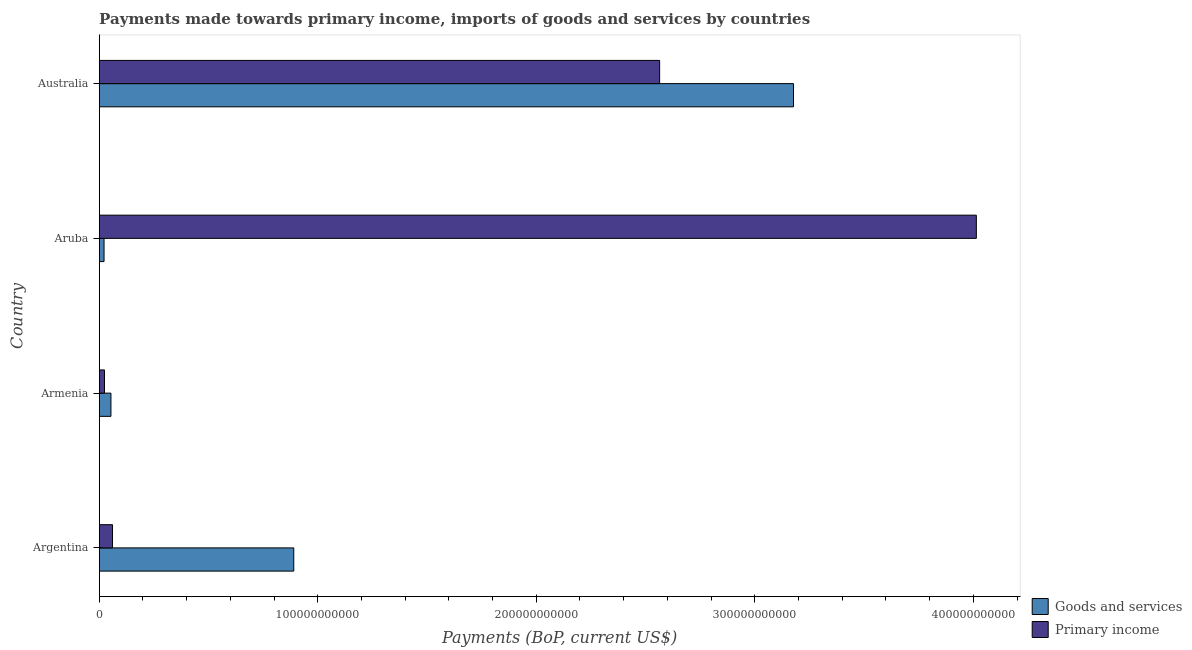How many different coloured bars are there?
Your answer should be compact. 2. How many groups of bars are there?
Give a very brief answer. 4. Are the number of bars per tick equal to the number of legend labels?
Your answer should be very brief. Yes. Are the number of bars on each tick of the Y-axis equal?
Provide a short and direct response. Yes. How many bars are there on the 1st tick from the bottom?
Offer a very short reply. 2. What is the label of the 4th group of bars from the top?
Provide a succinct answer. Argentina. In how many cases, is the number of bars for a given country not equal to the number of legend labels?
Your answer should be very brief. 0. What is the payments made towards goods and services in Aruba?
Provide a short and direct response. 2.21e+09. Across all countries, what is the maximum payments made towards goods and services?
Offer a terse response. 3.18e+11. Across all countries, what is the minimum payments made towards primary income?
Make the answer very short. 2.41e+09. In which country was the payments made towards goods and services maximum?
Ensure brevity in your answer.  Australia. In which country was the payments made towards primary income minimum?
Your answer should be very brief. Armenia. What is the total payments made towards goods and services in the graph?
Your answer should be compact. 4.14e+11. What is the difference between the payments made towards primary income in Armenia and that in Australia?
Offer a terse response. -2.54e+11. What is the difference between the payments made towards goods and services in Australia and the payments made towards primary income in Armenia?
Ensure brevity in your answer.  3.15e+11. What is the average payments made towards primary income per country?
Give a very brief answer. 1.67e+11. What is the difference between the payments made towards goods and services and payments made towards primary income in Argentina?
Your answer should be very brief. 8.29e+1. What is the ratio of the payments made towards primary income in Argentina to that in Armenia?
Your response must be concise. 2.52. Is the payments made towards goods and services in Armenia less than that in Australia?
Your answer should be compact. Yes. Is the difference between the payments made towards goods and services in Argentina and Australia greater than the difference between the payments made towards primary income in Argentina and Australia?
Keep it short and to the point. Yes. What is the difference between the highest and the second highest payments made towards primary income?
Your response must be concise. 1.45e+11. What is the difference between the highest and the lowest payments made towards goods and services?
Your response must be concise. 3.15e+11. In how many countries, is the payments made towards primary income greater than the average payments made towards primary income taken over all countries?
Give a very brief answer. 2. What does the 2nd bar from the top in Armenia represents?
Offer a very short reply. Goods and services. What does the 1st bar from the bottom in Argentina represents?
Offer a very short reply. Goods and services. How many bars are there?
Ensure brevity in your answer.  8. How many countries are there in the graph?
Offer a terse response. 4. What is the difference between two consecutive major ticks on the X-axis?
Your answer should be very brief. 1.00e+11. Are the values on the major ticks of X-axis written in scientific E-notation?
Provide a short and direct response. No. Does the graph contain any zero values?
Your answer should be very brief. No. Does the graph contain grids?
Provide a short and direct response. No. How many legend labels are there?
Make the answer very short. 2. What is the title of the graph?
Your response must be concise. Payments made towards primary income, imports of goods and services by countries. Does "ODA received" appear as one of the legend labels in the graph?
Offer a terse response. No. What is the label or title of the X-axis?
Ensure brevity in your answer.  Payments (BoP, current US$). What is the label or title of the Y-axis?
Offer a very short reply. Country. What is the Payments (BoP, current US$) in Goods and services in Argentina?
Provide a short and direct response. 8.90e+1. What is the Payments (BoP, current US$) in Primary income in Argentina?
Make the answer very short. 6.08e+09. What is the Payments (BoP, current US$) of Goods and services in Armenia?
Your answer should be compact. 5.36e+09. What is the Payments (BoP, current US$) in Primary income in Armenia?
Your response must be concise. 2.41e+09. What is the Payments (BoP, current US$) in Goods and services in Aruba?
Offer a terse response. 2.21e+09. What is the Payments (BoP, current US$) in Primary income in Aruba?
Make the answer very short. 4.01e+11. What is the Payments (BoP, current US$) in Goods and services in Australia?
Give a very brief answer. 3.18e+11. What is the Payments (BoP, current US$) of Primary income in Australia?
Your answer should be very brief. 2.56e+11. Across all countries, what is the maximum Payments (BoP, current US$) of Goods and services?
Give a very brief answer. 3.18e+11. Across all countries, what is the maximum Payments (BoP, current US$) in Primary income?
Keep it short and to the point. 4.01e+11. Across all countries, what is the minimum Payments (BoP, current US$) in Goods and services?
Make the answer very short. 2.21e+09. Across all countries, what is the minimum Payments (BoP, current US$) in Primary income?
Give a very brief answer. 2.41e+09. What is the total Payments (BoP, current US$) of Goods and services in the graph?
Ensure brevity in your answer.  4.14e+11. What is the total Payments (BoP, current US$) of Primary income in the graph?
Your response must be concise. 6.66e+11. What is the difference between the Payments (BoP, current US$) in Goods and services in Argentina and that in Armenia?
Make the answer very short. 8.37e+1. What is the difference between the Payments (BoP, current US$) of Primary income in Argentina and that in Armenia?
Your response must be concise. 3.67e+09. What is the difference between the Payments (BoP, current US$) of Goods and services in Argentina and that in Aruba?
Ensure brevity in your answer.  8.68e+1. What is the difference between the Payments (BoP, current US$) in Primary income in Argentina and that in Aruba?
Your response must be concise. -3.95e+11. What is the difference between the Payments (BoP, current US$) in Goods and services in Argentina and that in Australia?
Provide a succinct answer. -2.29e+11. What is the difference between the Payments (BoP, current US$) of Primary income in Argentina and that in Australia?
Keep it short and to the point. -2.50e+11. What is the difference between the Payments (BoP, current US$) of Goods and services in Armenia and that in Aruba?
Your answer should be compact. 3.16e+09. What is the difference between the Payments (BoP, current US$) in Primary income in Armenia and that in Aruba?
Offer a terse response. -3.99e+11. What is the difference between the Payments (BoP, current US$) of Goods and services in Armenia and that in Australia?
Ensure brevity in your answer.  -3.12e+11. What is the difference between the Payments (BoP, current US$) in Primary income in Armenia and that in Australia?
Your answer should be compact. -2.54e+11. What is the difference between the Payments (BoP, current US$) of Goods and services in Aruba and that in Australia?
Provide a succinct answer. -3.15e+11. What is the difference between the Payments (BoP, current US$) in Primary income in Aruba and that in Australia?
Your answer should be very brief. 1.45e+11. What is the difference between the Payments (BoP, current US$) of Goods and services in Argentina and the Payments (BoP, current US$) of Primary income in Armenia?
Your answer should be compact. 8.66e+1. What is the difference between the Payments (BoP, current US$) of Goods and services in Argentina and the Payments (BoP, current US$) of Primary income in Aruba?
Keep it short and to the point. -3.12e+11. What is the difference between the Payments (BoP, current US$) in Goods and services in Argentina and the Payments (BoP, current US$) in Primary income in Australia?
Provide a short and direct response. -1.67e+11. What is the difference between the Payments (BoP, current US$) of Goods and services in Armenia and the Payments (BoP, current US$) of Primary income in Aruba?
Give a very brief answer. -3.96e+11. What is the difference between the Payments (BoP, current US$) in Goods and services in Armenia and the Payments (BoP, current US$) in Primary income in Australia?
Offer a very short reply. -2.51e+11. What is the difference between the Payments (BoP, current US$) of Goods and services in Aruba and the Payments (BoP, current US$) of Primary income in Australia?
Your answer should be compact. -2.54e+11. What is the average Payments (BoP, current US$) in Goods and services per country?
Your answer should be very brief. 1.04e+11. What is the average Payments (BoP, current US$) of Primary income per country?
Your answer should be very brief. 1.67e+11. What is the difference between the Payments (BoP, current US$) in Goods and services and Payments (BoP, current US$) in Primary income in Argentina?
Offer a terse response. 8.29e+1. What is the difference between the Payments (BoP, current US$) in Goods and services and Payments (BoP, current US$) in Primary income in Armenia?
Your answer should be very brief. 2.95e+09. What is the difference between the Payments (BoP, current US$) in Goods and services and Payments (BoP, current US$) in Primary income in Aruba?
Keep it short and to the point. -3.99e+11. What is the difference between the Payments (BoP, current US$) of Goods and services and Payments (BoP, current US$) of Primary income in Australia?
Offer a very short reply. 6.13e+1. What is the ratio of the Payments (BoP, current US$) in Goods and services in Argentina to that in Armenia?
Your answer should be very brief. 16.59. What is the ratio of the Payments (BoP, current US$) of Primary income in Argentina to that in Armenia?
Keep it short and to the point. 2.52. What is the ratio of the Payments (BoP, current US$) of Goods and services in Argentina to that in Aruba?
Ensure brevity in your answer.  40.29. What is the ratio of the Payments (BoP, current US$) of Primary income in Argentina to that in Aruba?
Offer a very short reply. 0.02. What is the ratio of the Payments (BoP, current US$) of Goods and services in Argentina to that in Australia?
Offer a terse response. 0.28. What is the ratio of the Payments (BoP, current US$) in Primary income in Argentina to that in Australia?
Offer a terse response. 0.02. What is the ratio of the Payments (BoP, current US$) in Goods and services in Armenia to that in Aruba?
Offer a very short reply. 2.43. What is the ratio of the Payments (BoP, current US$) in Primary income in Armenia to that in Aruba?
Give a very brief answer. 0.01. What is the ratio of the Payments (BoP, current US$) of Goods and services in Armenia to that in Australia?
Your answer should be very brief. 0.02. What is the ratio of the Payments (BoP, current US$) in Primary income in Armenia to that in Australia?
Provide a short and direct response. 0.01. What is the ratio of the Payments (BoP, current US$) of Goods and services in Aruba to that in Australia?
Provide a succinct answer. 0.01. What is the ratio of the Payments (BoP, current US$) of Primary income in Aruba to that in Australia?
Your answer should be very brief. 1.57. What is the difference between the highest and the second highest Payments (BoP, current US$) of Goods and services?
Ensure brevity in your answer.  2.29e+11. What is the difference between the highest and the second highest Payments (BoP, current US$) in Primary income?
Keep it short and to the point. 1.45e+11. What is the difference between the highest and the lowest Payments (BoP, current US$) in Goods and services?
Offer a terse response. 3.15e+11. What is the difference between the highest and the lowest Payments (BoP, current US$) of Primary income?
Make the answer very short. 3.99e+11. 